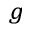Convert formula to latex. <formula><loc_0><loc_0><loc_500><loc_500>^ { g }</formula> 